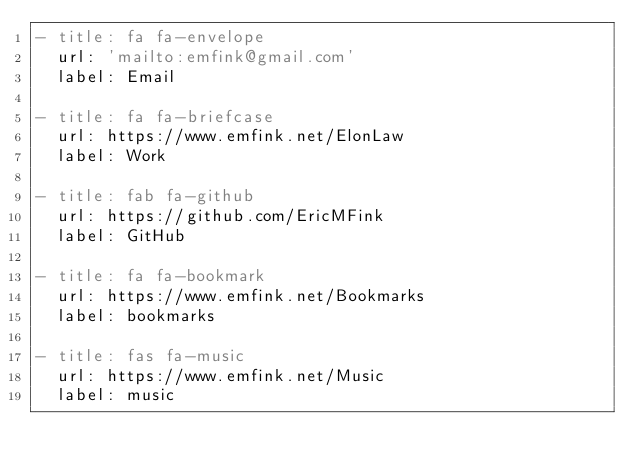<code> <loc_0><loc_0><loc_500><loc_500><_YAML_>- title: fa fa-envelope
  url: 'mailto:emfink@gmail.com'
  label: Email

- title: fa fa-briefcase
  url: https://www.emfink.net/ElonLaw
  label: Work

- title: fab fa-github
  url: https://github.com/EricMFink
  label: GitHub

- title: fa fa-bookmark
  url: https://www.emfink.net/Bookmarks
  label: bookmarks

- title: fas fa-music
  url: https://www.emfink.net/Music
  label: music</code> 